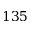Convert formula to latex. <formula><loc_0><loc_0><loc_500><loc_500>1 3 5</formula> 